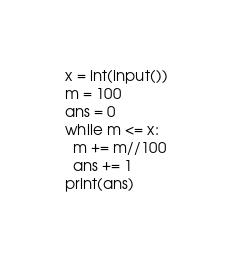<code> <loc_0><loc_0><loc_500><loc_500><_Python_>x = int(input())
m = 100
ans = 0
while m <= x:
  m += m//100
  ans += 1
print(ans)</code> 